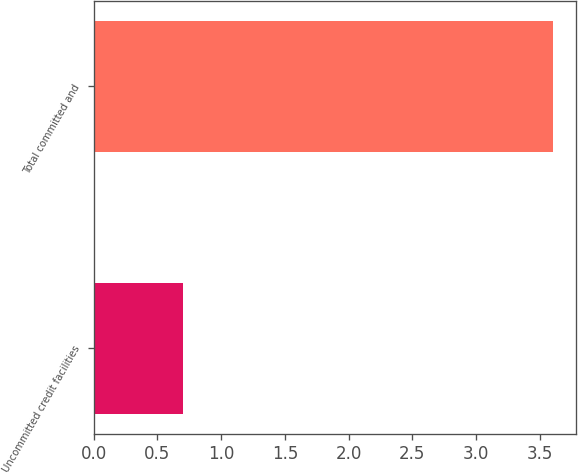Convert chart. <chart><loc_0><loc_0><loc_500><loc_500><bar_chart><fcel>Uncommitted credit facilities<fcel>Total committed and<nl><fcel>0.7<fcel>3.6<nl></chart> 